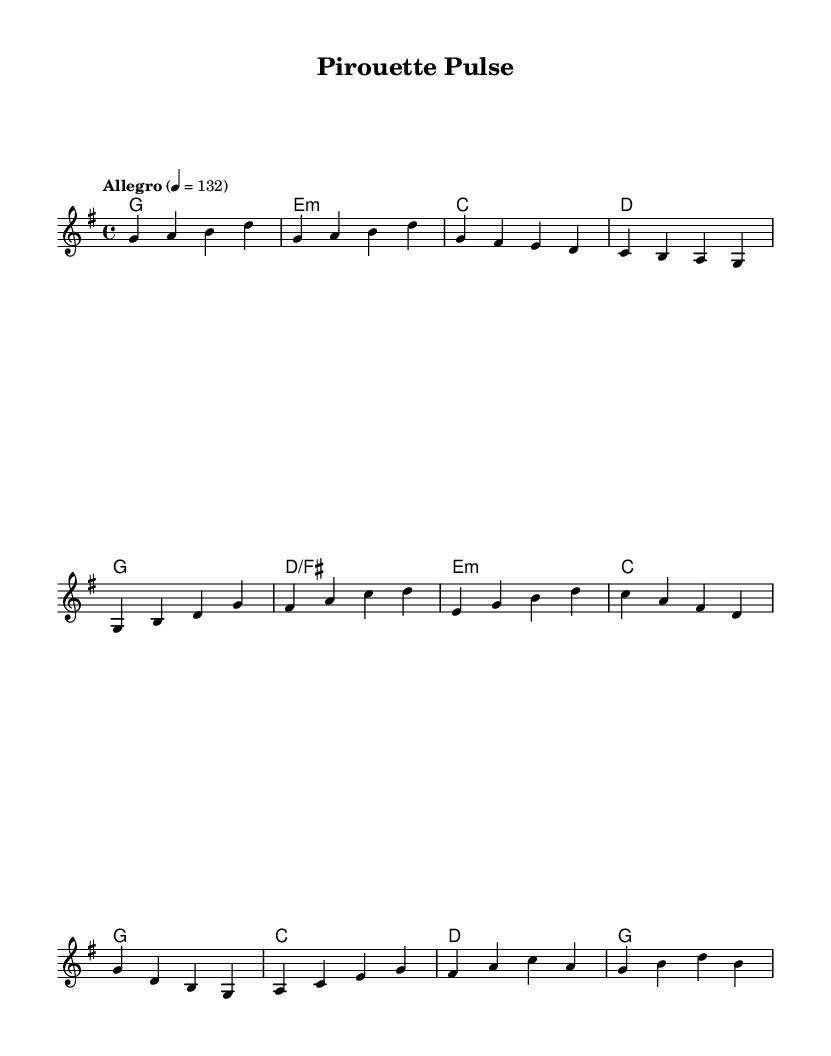What is the key signature of this music? The key signature is based on the notes played, and in this case, it is indicated by the presence of the F sharp. This corresponds to G major, which has one sharp.
Answer: G major What is the time signature of this piece? The time signature is indicated at the beginning of the score and shows how many beats are in each measure. Here, it is 4/4, meaning there are four beats per measure.
Answer: 4/4 What is the tempo marking for the piece? The tempo marking indicates the speed of the piece and is found at the top. Here it indicates "Allegro" with a metronome marking of 132 beats per minute.
Answer: Allegro, 132 What are the first four notes of the melody? The first four notes are specified in the score directly after the introduction. They are G, A, B, and D.
Answer: G, A, B, D How many measures are there in the chorus? By counting the sections notated in the score, the chorus has a total of four measures.
Answer: 4 What harmonic structure is used in the verse? The harmonic structure is based on identifying the chords being played during the verse, and they show a progression from G to D/F#, E minor, and C. This indicates a typical pop structure.
Answer: G, D/F#, E minor, C Which chord is held for the entirety of the first measure? The first measure contains only one chord, G major, which is played as a whole note across the measure.
Answer: G major 